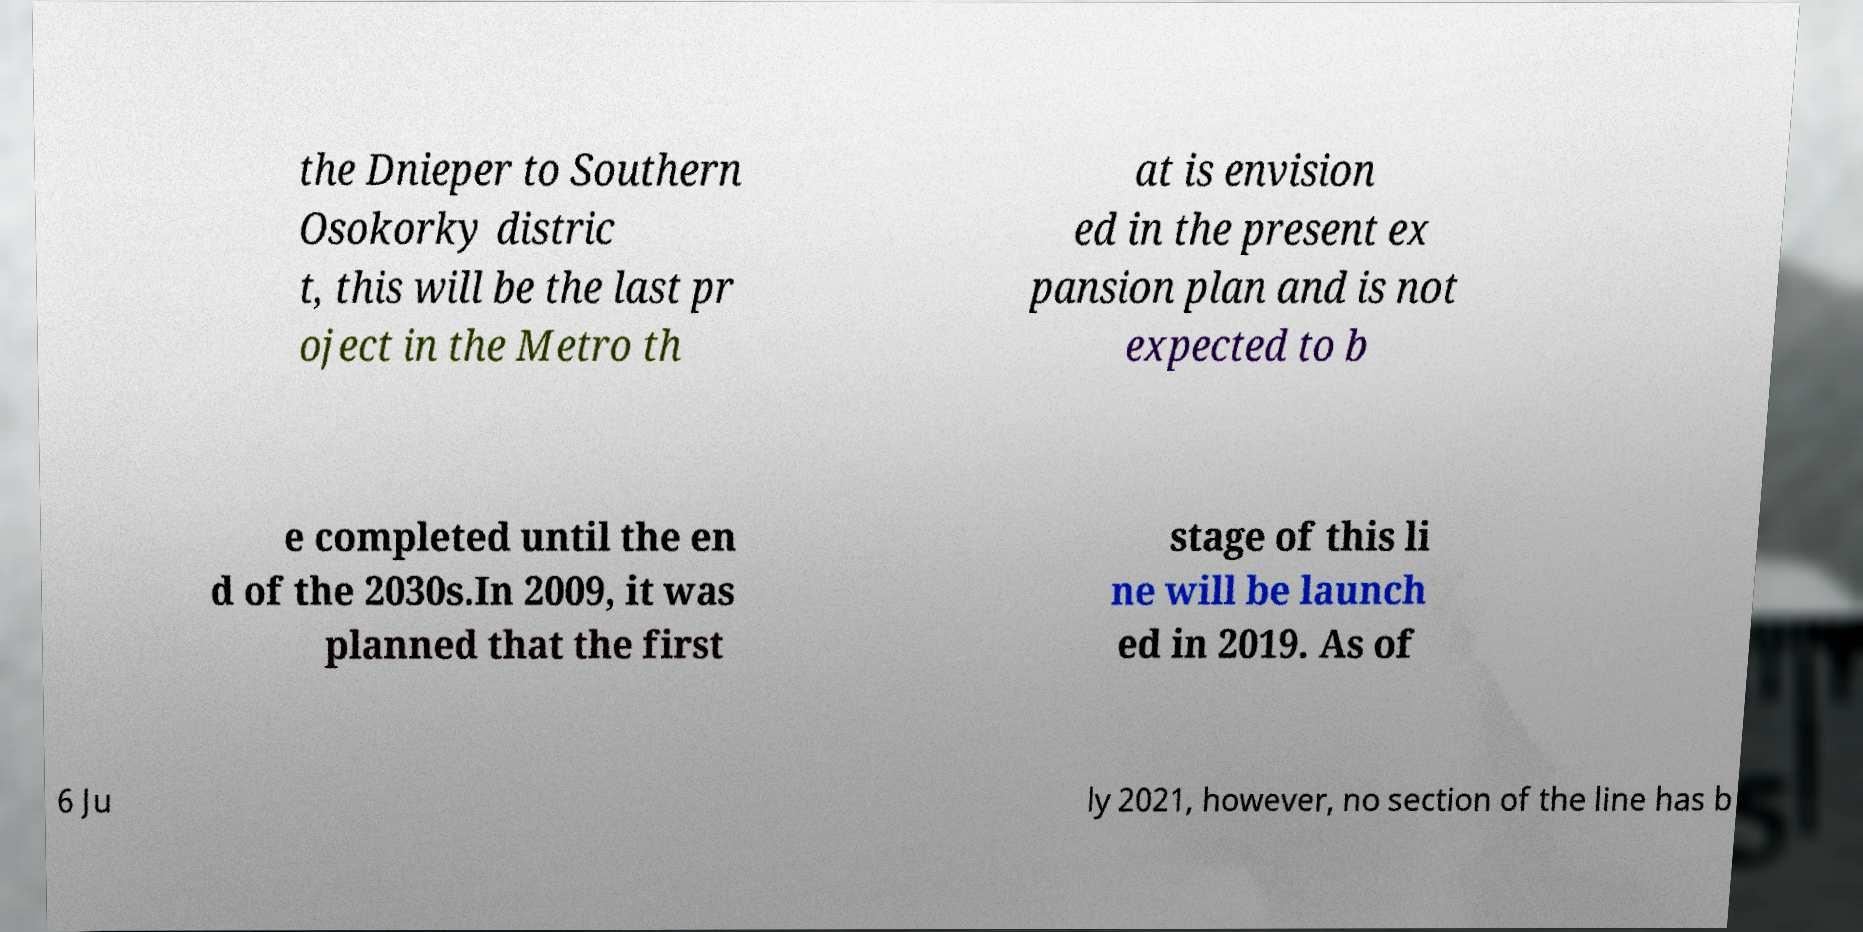I need the written content from this picture converted into text. Can you do that? the Dnieper to Southern Osokorky distric t, this will be the last pr oject in the Metro th at is envision ed in the present ex pansion plan and is not expected to b e completed until the en d of the 2030s.In 2009, it was planned that the first stage of this li ne will be launch ed in 2019. As of 6 Ju ly 2021, however, no section of the line has b 